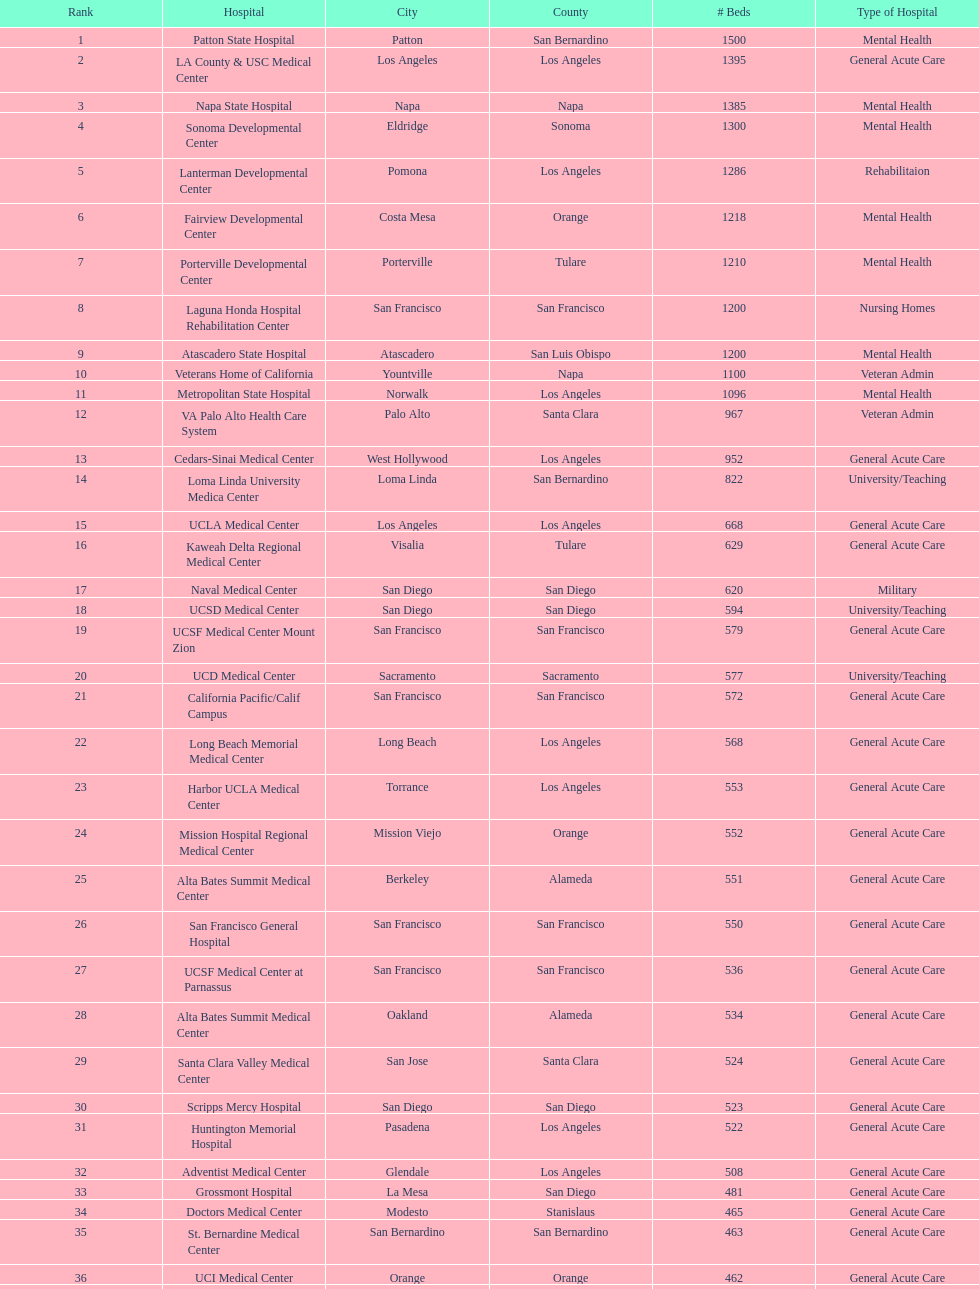Does patton state hospital have a higher capacity for mental health hospital beds compared to atascadero state hospital? Yes. 